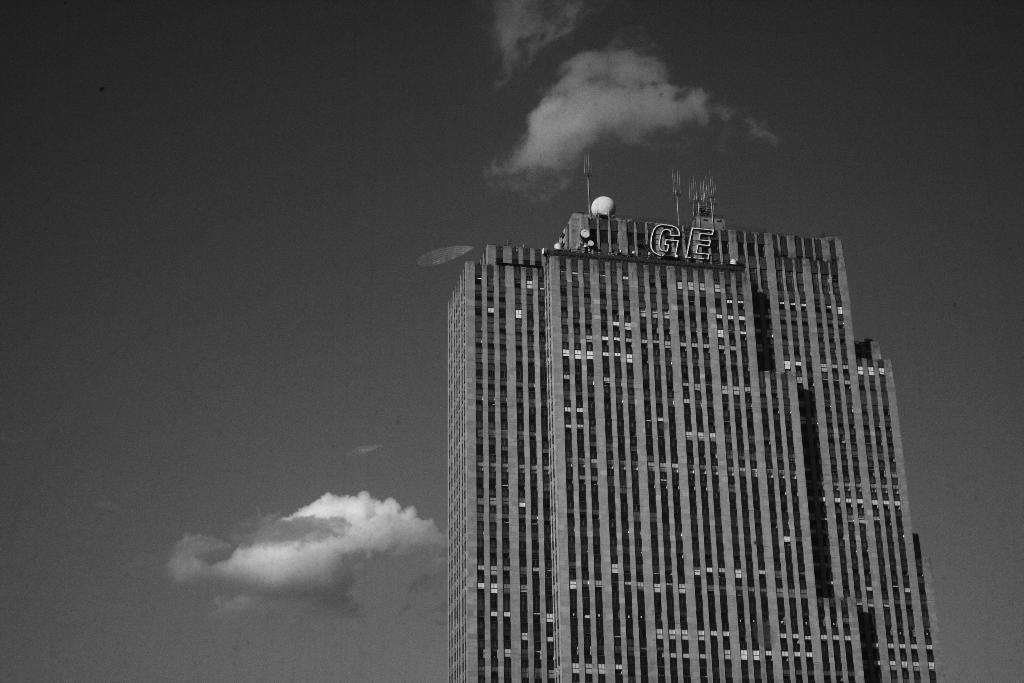Can you describe this image briefly? In this image I can see a building, background I can see the sky and the image is in black and white. 